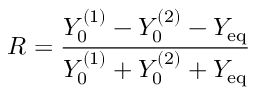Convert formula to latex. <formula><loc_0><loc_0><loc_500><loc_500>R = \frac { Y _ { 0 } ^ { ( 1 ) } - Y _ { 0 } ^ { ( 2 ) } - Y _ { e q } } { Y _ { 0 } ^ { ( 1 ) } + Y _ { 0 } ^ { ( 2 ) } + Y _ { e q } }</formula> 